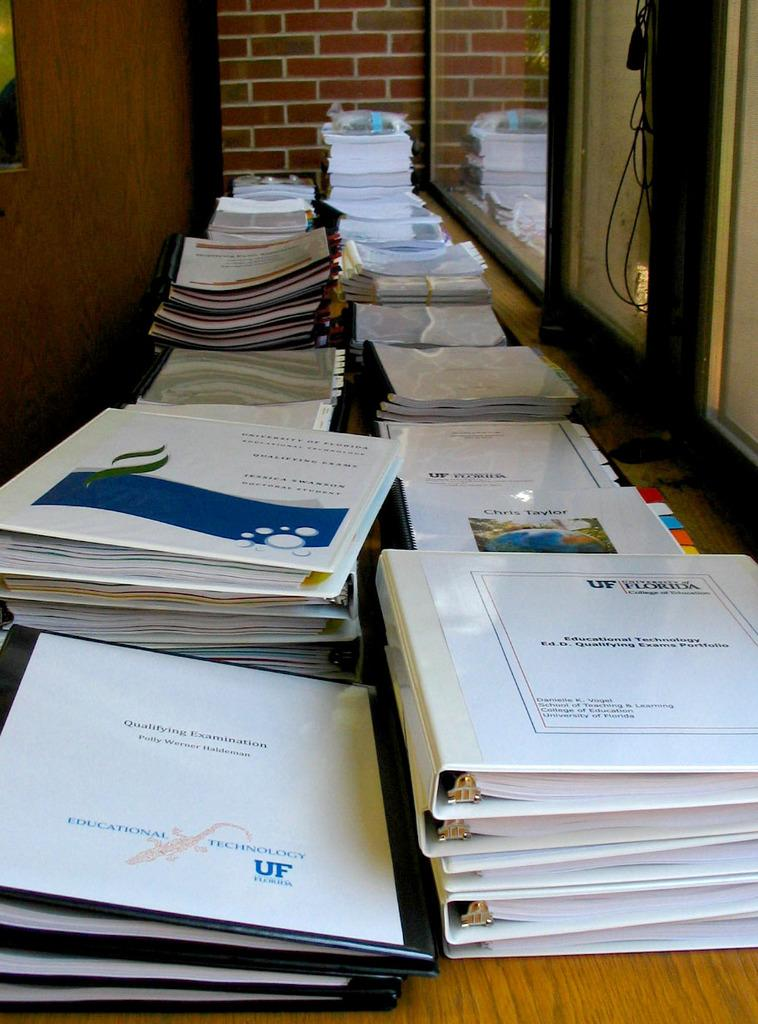<image>
Describe the image concisely. A binder that says Technology UF sits with many other binders on a table. 